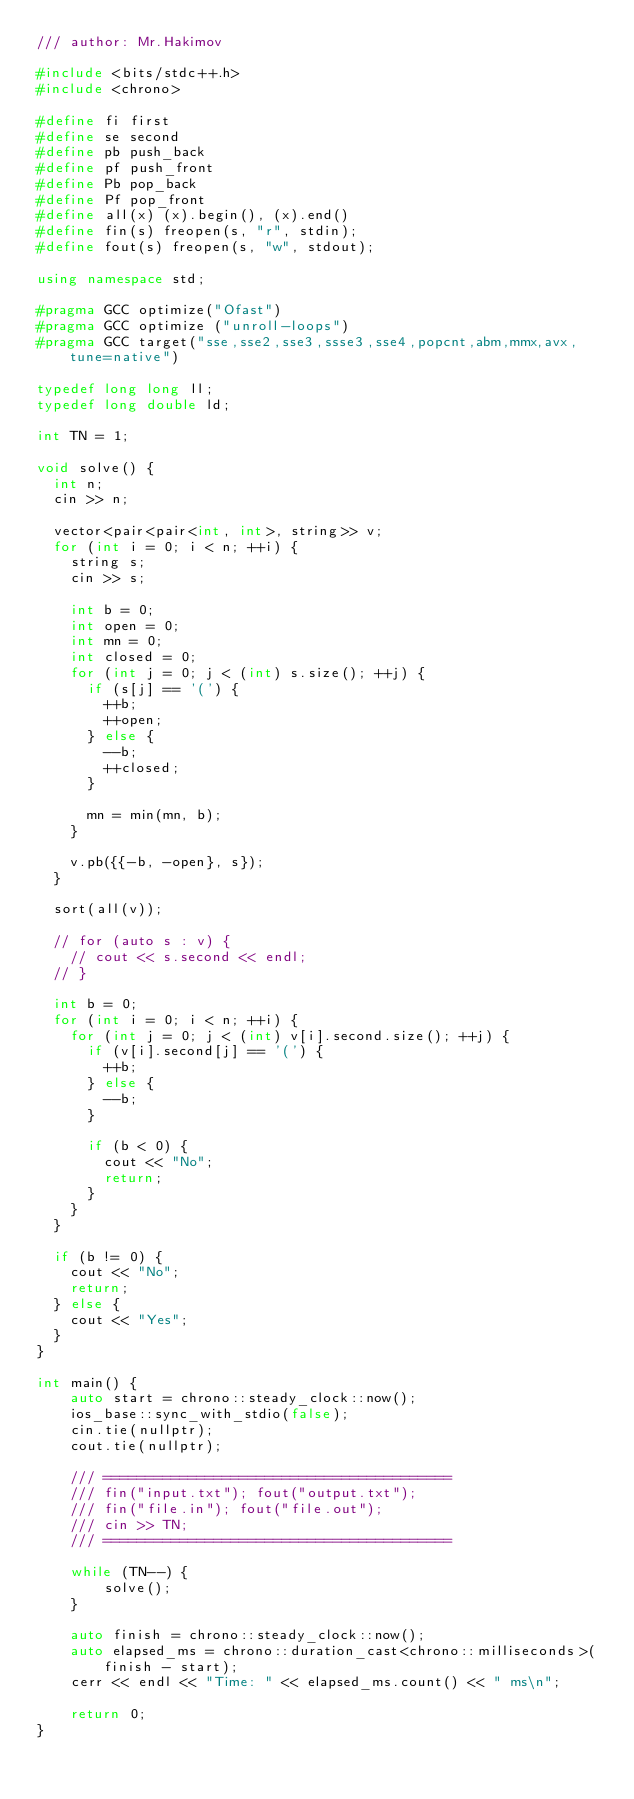<code> <loc_0><loc_0><loc_500><loc_500><_C++_>/// author: Mr.Hakimov

#include <bits/stdc++.h>
#include <chrono>

#define fi first
#define se second
#define pb push_back
#define pf push_front
#define Pb pop_back
#define Pf pop_front
#define all(x) (x).begin(), (x).end()
#define fin(s) freopen(s, "r", stdin);
#define fout(s) freopen(s, "w", stdout);

using namespace std;

#pragma GCC optimize("Ofast")
#pragma GCC optimize ("unroll-loops")
#pragma GCC target("sse,sse2,sse3,ssse3,sse4,popcnt,abm,mmx,avx,tune=native")

typedef long long ll;
typedef long double ld;

int TN = 1;

void solve() {
	int n;
	cin >> n;
	
	vector<pair<pair<int, int>, string>> v;
	for (int i = 0; i < n; ++i) {
		string s;
		cin >> s;
		
		int b = 0;
		int open = 0;
		int mn = 0;
		int closed = 0;
		for (int j = 0; j < (int) s.size(); ++j) {
			if (s[j] == '(') {
				++b;
				++open;
			} else {
				--b;
				++closed;
			}
			
			mn = min(mn, b);
		}
		
		v.pb({{-b, -open}, s});
	}
	
	sort(all(v));
	
	// for (auto s : v) {
		// cout << s.second << endl;
	// }
	
	int b = 0;
	for (int i = 0; i < n; ++i) {
		for (int j = 0; j < (int) v[i].second.size(); ++j) {
			if (v[i].second[j] == '(') {
				++b;
			} else {
				--b;
			}
			
			if (b < 0) {
				cout << "No";
				return;
			}
		}
	}
	
	if (b != 0) {
		cout << "No";
		return;
	} else {
		cout << "Yes";
	}
}

int main() {
    auto start = chrono::steady_clock::now();
    ios_base::sync_with_stdio(false);
    cin.tie(nullptr);
    cout.tie(nullptr);

    /// =========================================
    /// fin("input.txt"); fout("output.txt");
    /// fin("file.in"); fout("file.out");
    /// cin >> TN;
    /// =========================================

    while (TN--) {
        solve();
    }

    auto finish = chrono::steady_clock::now();
    auto elapsed_ms = chrono::duration_cast<chrono::milliseconds>(finish - start);
    cerr << endl << "Time: " << elapsed_ms.count() << " ms\n";

    return 0;
}
</code> 